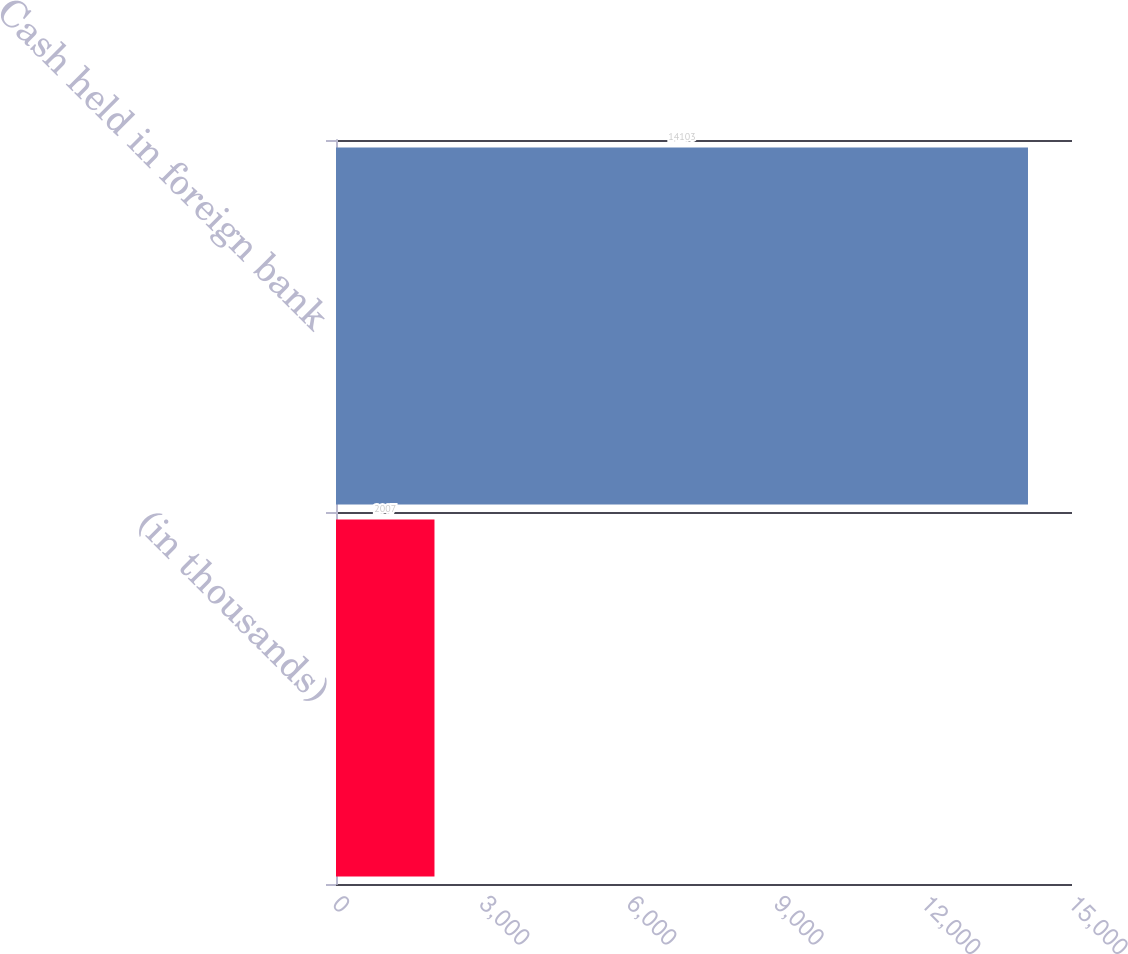Convert chart. <chart><loc_0><loc_0><loc_500><loc_500><bar_chart><fcel>(in thousands)<fcel>Cash held in foreign bank<nl><fcel>2007<fcel>14103<nl></chart> 